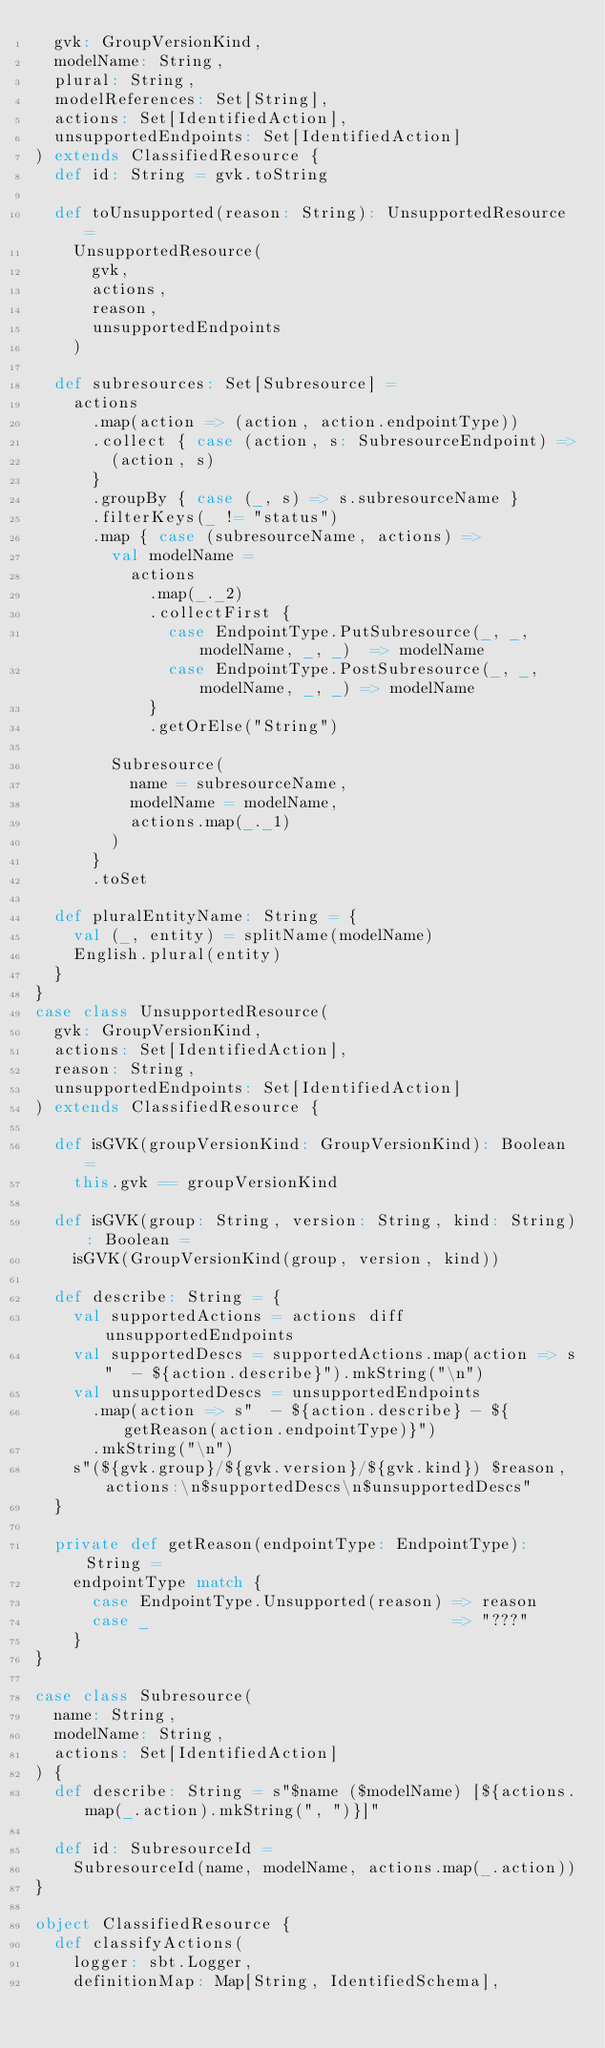<code> <loc_0><loc_0><loc_500><loc_500><_Scala_>  gvk: GroupVersionKind,
  modelName: String,
  plural: String,
  modelReferences: Set[String],
  actions: Set[IdentifiedAction],
  unsupportedEndpoints: Set[IdentifiedAction]
) extends ClassifiedResource {
  def id: String = gvk.toString

  def toUnsupported(reason: String): UnsupportedResource =
    UnsupportedResource(
      gvk,
      actions,
      reason,
      unsupportedEndpoints
    )

  def subresources: Set[Subresource] =
    actions
      .map(action => (action, action.endpointType))
      .collect { case (action, s: SubresourceEndpoint) =>
        (action, s)
      }
      .groupBy { case (_, s) => s.subresourceName }
      .filterKeys(_ != "status")
      .map { case (subresourceName, actions) =>
        val modelName =
          actions
            .map(_._2)
            .collectFirst {
              case EndpointType.PutSubresource(_, _, modelName, _, _)  => modelName
              case EndpointType.PostSubresource(_, _, modelName, _, _) => modelName
            }
            .getOrElse("String")

        Subresource(
          name = subresourceName,
          modelName = modelName,
          actions.map(_._1)
        )
      }
      .toSet

  def pluralEntityName: String = {
    val (_, entity) = splitName(modelName)
    English.plural(entity)
  }
}
case class UnsupportedResource(
  gvk: GroupVersionKind,
  actions: Set[IdentifiedAction],
  reason: String,
  unsupportedEndpoints: Set[IdentifiedAction]
) extends ClassifiedResource {

  def isGVK(groupVersionKind: GroupVersionKind): Boolean =
    this.gvk == groupVersionKind

  def isGVK(group: String, version: String, kind: String): Boolean =
    isGVK(GroupVersionKind(group, version, kind))

  def describe: String = {
    val supportedActions = actions diff unsupportedEndpoints
    val supportedDescs = supportedActions.map(action => s"  - ${action.describe}").mkString("\n")
    val unsupportedDescs = unsupportedEndpoints
      .map(action => s"  - ${action.describe} - ${getReason(action.endpointType)}")
      .mkString("\n")
    s"(${gvk.group}/${gvk.version}/${gvk.kind}) $reason, actions:\n$supportedDescs\n$unsupportedDescs"
  }

  private def getReason(endpointType: EndpointType): String =
    endpointType match {
      case EndpointType.Unsupported(reason) => reason
      case _                                => "???"
    }
}

case class Subresource(
  name: String,
  modelName: String,
  actions: Set[IdentifiedAction]
) {
  def describe: String = s"$name ($modelName) [${actions.map(_.action).mkString(", ")}]"

  def id: SubresourceId =
    SubresourceId(name, modelName, actions.map(_.action))
}

object ClassifiedResource {
  def classifyActions(
    logger: sbt.Logger,
    definitionMap: Map[String, IdentifiedSchema],</code> 